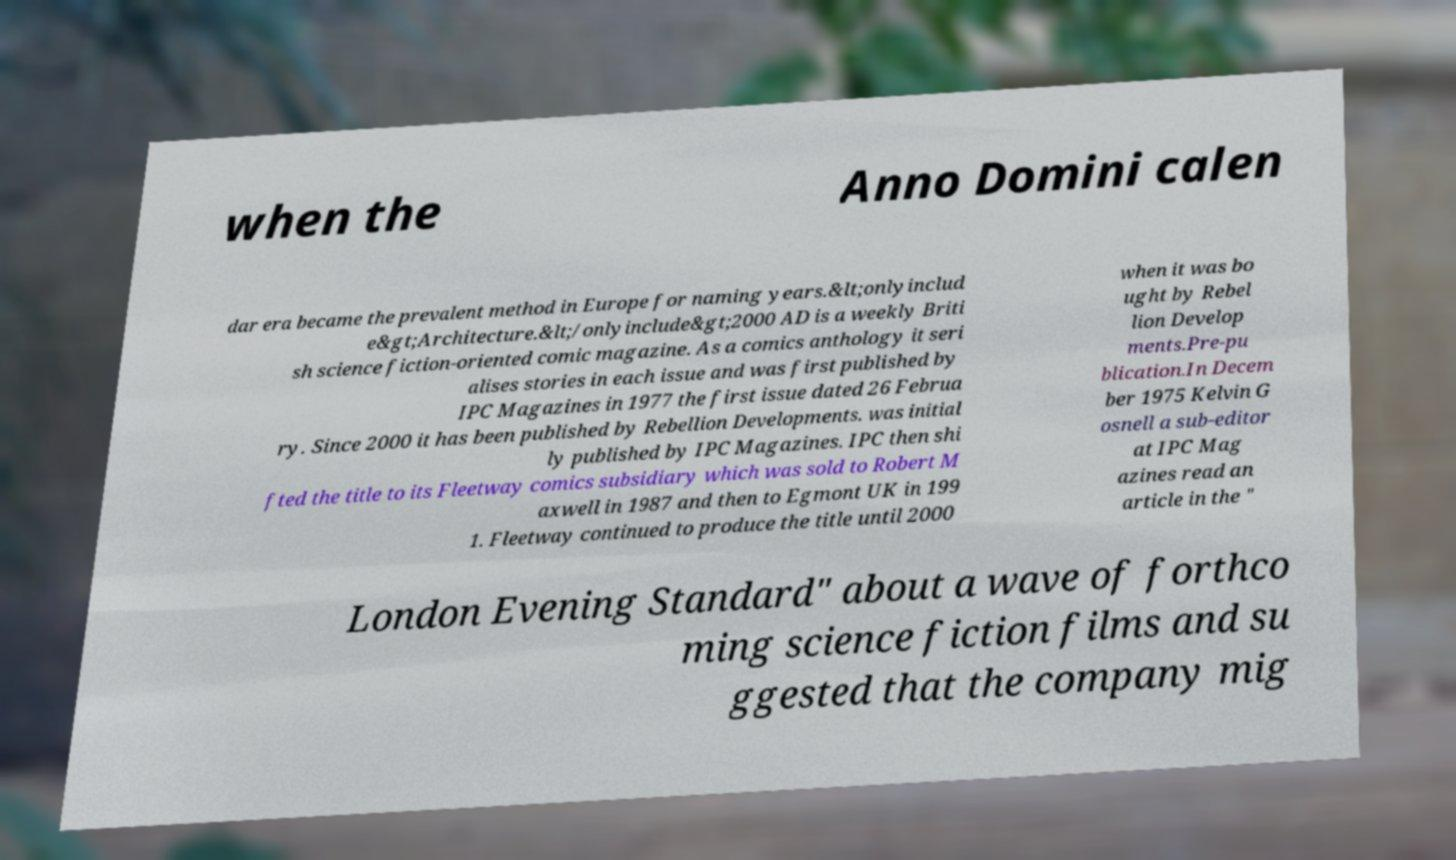Could you assist in decoding the text presented in this image and type it out clearly? when the Anno Domini calen dar era became the prevalent method in Europe for naming years.&lt;onlyinclud e&gt;Architecture.&lt;/onlyinclude&gt;2000 AD is a weekly Briti sh science fiction-oriented comic magazine. As a comics anthology it seri alises stories in each issue and was first published by IPC Magazines in 1977 the first issue dated 26 Februa ry. Since 2000 it has been published by Rebellion Developments. was initial ly published by IPC Magazines. IPC then shi fted the title to its Fleetway comics subsidiary which was sold to Robert M axwell in 1987 and then to Egmont UK in 199 1. Fleetway continued to produce the title until 2000 when it was bo ught by Rebel lion Develop ments.Pre-pu blication.In Decem ber 1975 Kelvin G osnell a sub-editor at IPC Mag azines read an article in the " London Evening Standard" about a wave of forthco ming science fiction films and su ggested that the company mig 